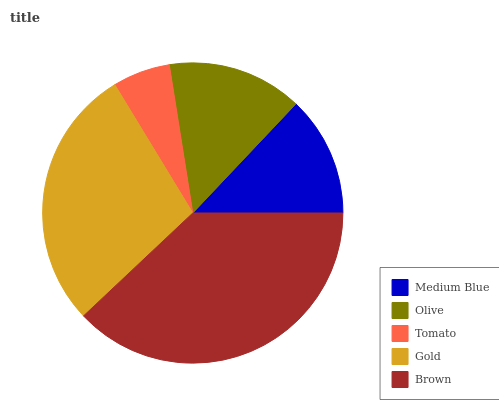Is Tomato the minimum?
Answer yes or no. Yes. Is Brown the maximum?
Answer yes or no. Yes. Is Olive the minimum?
Answer yes or no. No. Is Olive the maximum?
Answer yes or no. No. Is Olive greater than Medium Blue?
Answer yes or no. Yes. Is Medium Blue less than Olive?
Answer yes or no. Yes. Is Medium Blue greater than Olive?
Answer yes or no. No. Is Olive less than Medium Blue?
Answer yes or no. No. Is Olive the high median?
Answer yes or no. Yes. Is Olive the low median?
Answer yes or no. Yes. Is Medium Blue the high median?
Answer yes or no. No. Is Tomato the low median?
Answer yes or no. No. 